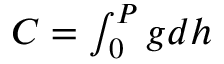Convert formula to latex. <formula><loc_0><loc_0><loc_500><loc_500>\begin{array} { r } { C = \int _ { 0 } ^ { P } g d h } \end{array}</formula> 